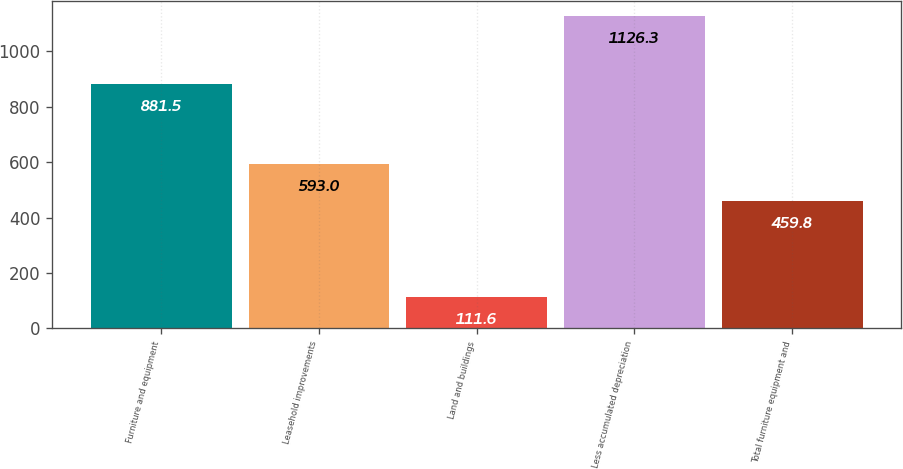Convert chart. <chart><loc_0><loc_0><loc_500><loc_500><bar_chart><fcel>Furniture and equipment<fcel>Leasehold improvements<fcel>Land and buildings<fcel>Less accumulated depreciation<fcel>Total furniture equipment and<nl><fcel>881.5<fcel>593<fcel>111.6<fcel>1126.3<fcel>459.8<nl></chart> 